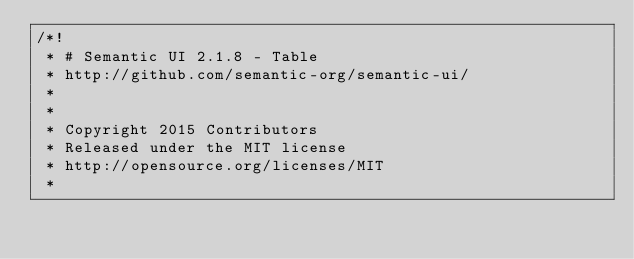<code> <loc_0><loc_0><loc_500><loc_500><_CSS_>/*!
 * # Semantic UI 2.1.8 - Table
 * http://github.com/semantic-org/semantic-ui/
 *
 *
 * Copyright 2015 Contributors
 * Released under the MIT license
 * http://opensource.org/licenses/MIT
 *</code> 